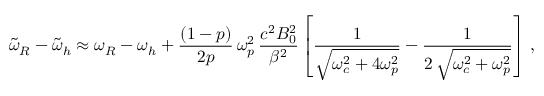<formula> <loc_0><loc_0><loc_500><loc_500>\widetilde { \omega } _ { R } - \widetilde { \omega } _ { h } \approx \omega _ { R } - \omega _ { h } + \frac { ( 1 - p ) } { 2 p } \, \omega _ { p } ^ { 2 } \, \frac { c ^ { 2 } B _ { 0 } ^ { 2 } } { \beta ^ { 2 } } \left [ \frac { 1 } { \sqrt { \omega _ { c } ^ { 2 } + 4 \omega _ { p } ^ { 2 } } } - \frac { 1 } { 2 \, \sqrt { \omega _ { c } ^ { 2 } + \omega _ { p } ^ { 2 } } } \right ] \, ,</formula> 